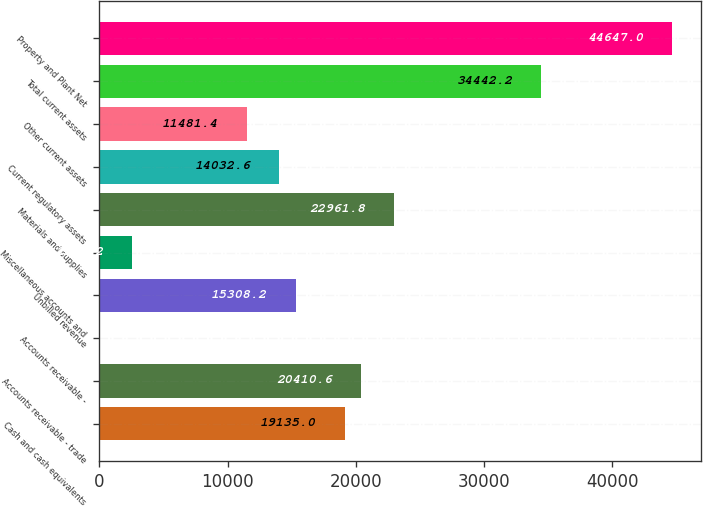<chart> <loc_0><loc_0><loc_500><loc_500><bar_chart><fcel>Cash and cash equivalents<fcel>Accounts receivable - trade<fcel>Accounts receivable -<fcel>Unbilled revenue<fcel>Miscellaneous accounts and<fcel>Materials and supplies<fcel>Current regulatory assets<fcel>Other current assets<fcel>Total current assets<fcel>Property and Plant Net<nl><fcel>19135<fcel>20410.6<fcel>1<fcel>15308.2<fcel>2552.2<fcel>22961.8<fcel>14032.6<fcel>11481.4<fcel>34442.2<fcel>44647<nl></chart> 